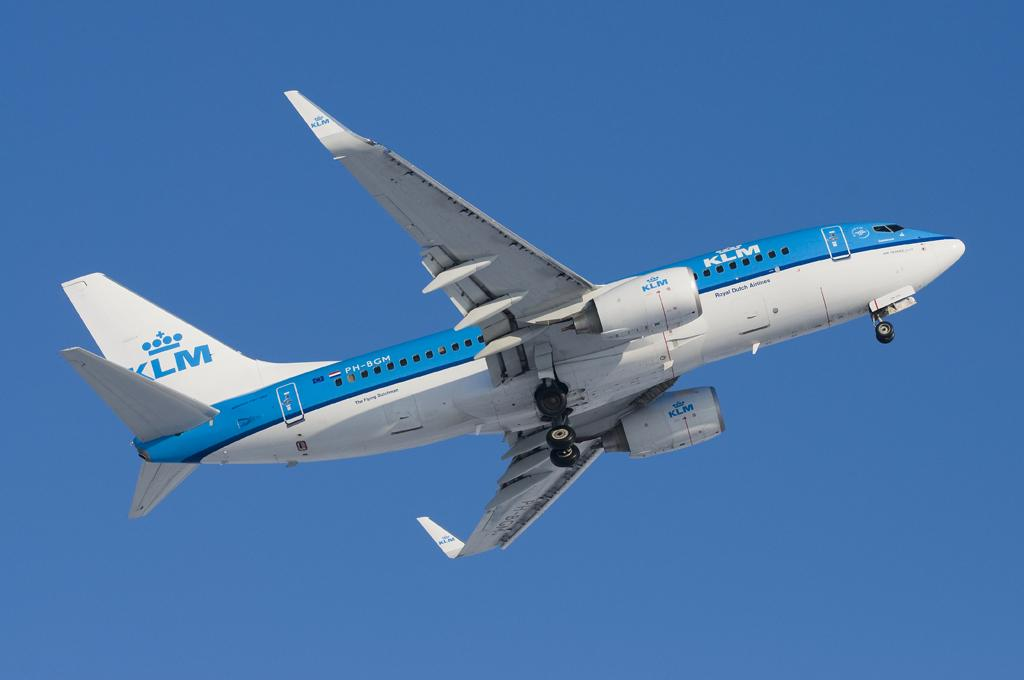What is the main subject of the image? There is an aeroplane in the center of the image. What can be seen in the background of the image? The sky is visible in the background of the image. What type of teaching is taking place in the image? There is no teaching activity present in the image; it features an aeroplane and the sky. Are there any mountains visible in the image? There are no mountains present in the image; it features an aeroplane and the sky. 